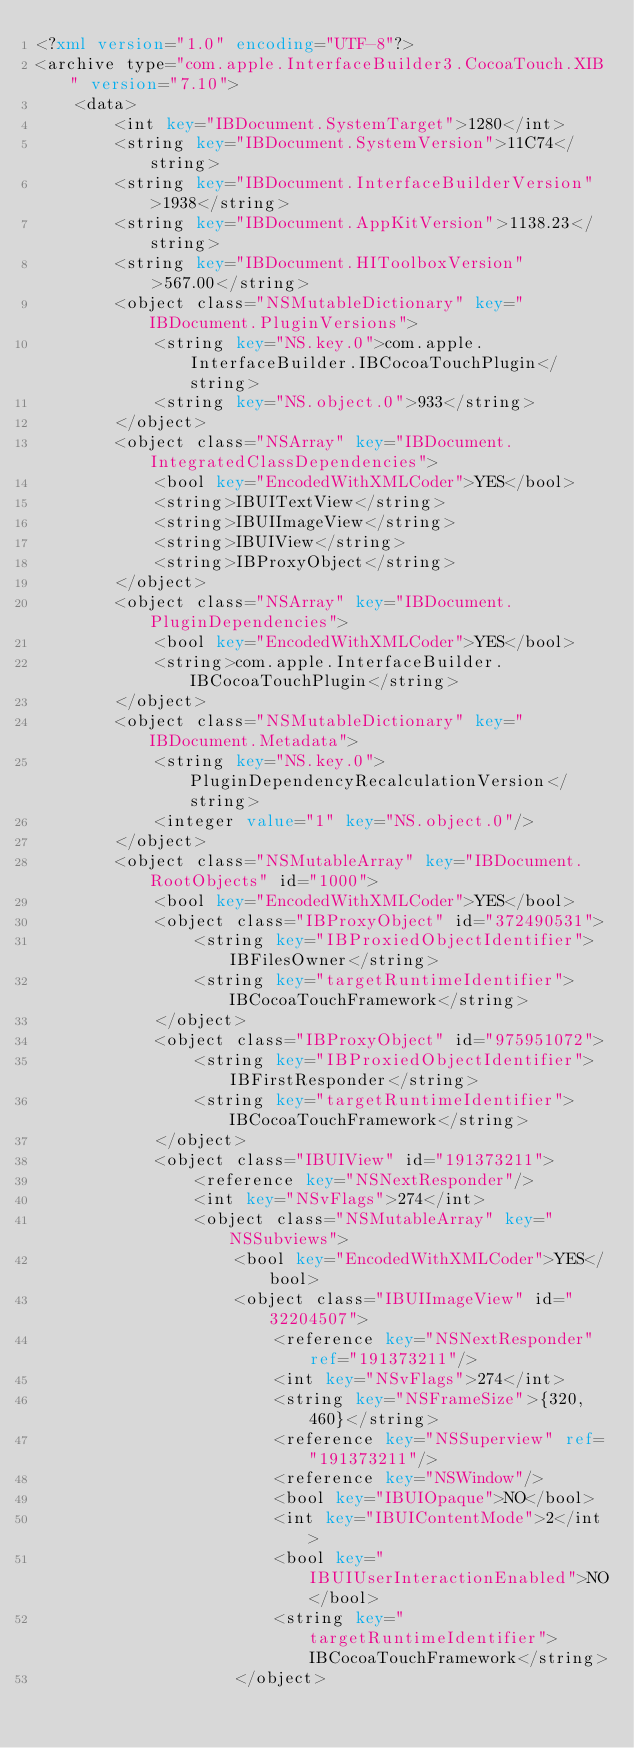Convert code to text. <code><loc_0><loc_0><loc_500><loc_500><_XML_><?xml version="1.0" encoding="UTF-8"?>
<archive type="com.apple.InterfaceBuilder3.CocoaTouch.XIB" version="7.10">
	<data>
		<int key="IBDocument.SystemTarget">1280</int>
		<string key="IBDocument.SystemVersion">11C74</string>
		<string key="IBDocument.InterfaceBuilderVersion">1938</string>
		<string key="IBDocument.AppKitVersion">1138.23</string>
		<string key="IBDocument.HIToolboxVersion">567.00</string>
		<object class="NSMutableDictionary" key="IBDocument.PluginVersions">
			<string key="NS.key.0">com.apple.InterfaceBuilder.IBCocoaTouchPlugin</string>
			<string key="NS.object.0">933</string>
		</object>
		<object class="NSArray" key="IBDocument.IntegratedClassDependencies">
			<bool key="EncodedWithXMLCoder">YES</bool>
			<string>IBUITextView</string>
			<string>IBUIImageView</string>
			<string>IBUIView</string>
			<string>IBProxyObject</string>
		</object>
		<object class="NSArray" key="IBDocument.PluginDependencies">
			<bool key="EncodedWithXMLCoder">YES</bool>
			<string>com.apple.InterfaceBuilder.IBCocoaTouchPlugin</string>
		</object>
		<object class="NSMutableDictionary" key="IBDocument.Metadata">
			<string key="NS.key.0">PluginDependencyRecalculationVersion</string>
			<integer value="1" key="NS.object.0"/>
		</object>
		<object class="NSMutableArray" key="IBDocument.RootObjects" id="1000">
			<bool key="EncodedWithXMLCoder">YES</bool>
			<object class="IBProxyObject" id="372490531">
				<string key="IBProxiedObjectIdentifier">IBFilesOwner</string>
				<string key="targetRuntimeIdentifier">IBCocoaTouchFramework</string>
			</object>
			<object class="IBProxyObject" id="975951072">
				<string key="IBProxiedObjectIdentifier">IBFirstResponder</string>
				<string key="targetRuntimeIdentifier">IBCocoaTouchFramework</string>
			</object>
			<object class="IBUIView" id="191373211">
				<reference key="NSNextResponder"/>
				<int key="NSvFlags">274</int>
				<object class="NSMutableArray" key="NSSubviews">
					<bool key="EncodedWithXMLCoder">YES</bool>
					<object class="IBUIImageView" id="32204507">
						<reference key="NSNextResponder" ref="191373211"/>
						<int key="NSvFlags">274</int>
						<string key="NSFrameSize">{320, 460}</string>
						<reference key="NSSuperview" ref="191373211"/>
						<reference key="NSWindow"/>
						<bool key="IBUIOpaque">NO</bool>
						<int key="IBUIContentMode">2</int>
						<bool key="IBUIUserInteractionEnabled">NO</bool>
						<string key="targetRuntimeIdentifier">IBCocoaTouchFramework</string>
					</object></code> 